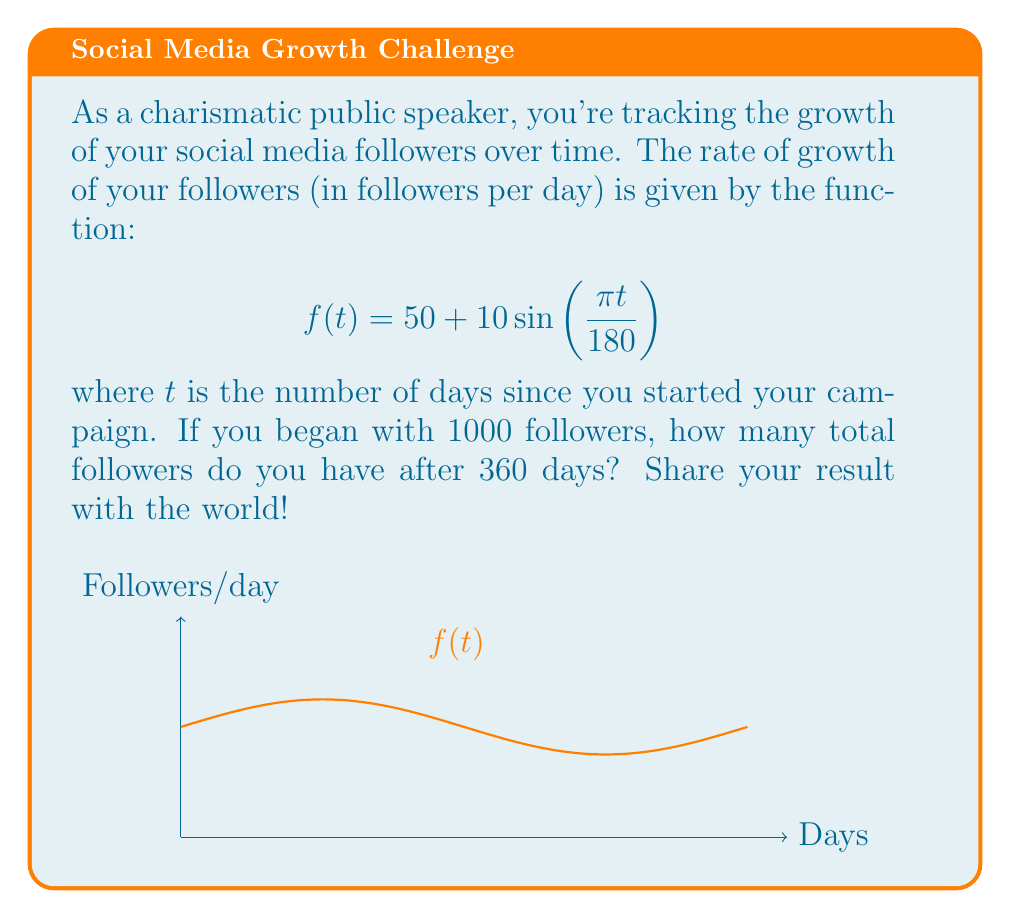Show me your answer to this math problem. Let's approach this step-by-step:

1) The total number of followers gained over 360 days is the area under the curve $f(t)$ from $t=0$ to $t=360$, plus the initial 1000 followers.

2) To find the area under the curve, we need to integrate $f(t)$ from 0 to 360:

   $$\int_0^{360} (50 + 10\sin(\frac{\pi t}{180})) dt$$

3) Let's break this into two parts:
   
   $$\int_0^{360} 50 dt + \int_0^{360} 10\sin(\frac{\pi t}{180}) dt$$

4) For the first part:
   
   $$\int_0^{360} 50 dt = 50t \big|_0^{360} = 50(360) - 50(0) = 18000$$

5) For the second part, let $u = \frac{\pi t}{180}$. Then $du = \frac{\pi}{180} dt$, or $dt = \frac{180}{\pi} du$:

   $$10 \int_0^{2\pi} \sin(u) \cdot \frac{180}{\pi} du = \frac{1800}{\pi} \int_0^{2\pi} \sin(u) du$$

6) We know that $\int_0^{2\pi} \sin(u) du = 0$, so this part equals 0.

7) Therefore, the total area under the curve is 18000.

8) Adding this to our initial 1000 followers:

   $$1000 + 18000 = 19000$$

Thus, after 360 days, you have 19000 followers.
Answer: 19000 followers 